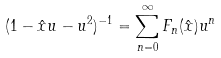Convert formula to latex. <formula><loc_0><loc_0><loc_500><loc_500>( 1 - { \hat { x } } u - u ^ { 2 } ) ^ { - 1 } = \sum _ { n = 0 } ^ { \infty } F _ { n } ( { \hat { x } } ) u ^ { n }</formula> 